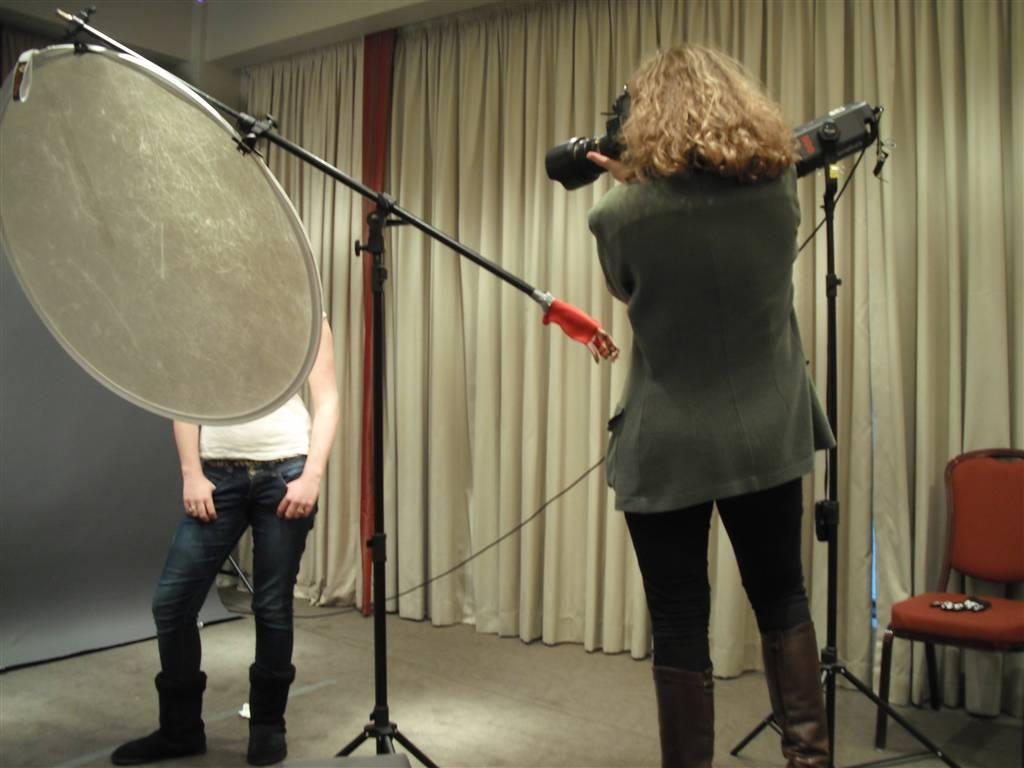How many people are present in the image? There are two persons in the image. What is one person doing in the image? One person is holding a camera. What objects can be seen in the image that are used for support? There are two stands in the image. What type of furniture is present in the image? There is a chair in the image. What type of window treatment is present in the room? There is a curtain in the room. What type of finger can be seen ordering food in the image? There is no finger present in the image, nor is there any indication of food being ordered. 